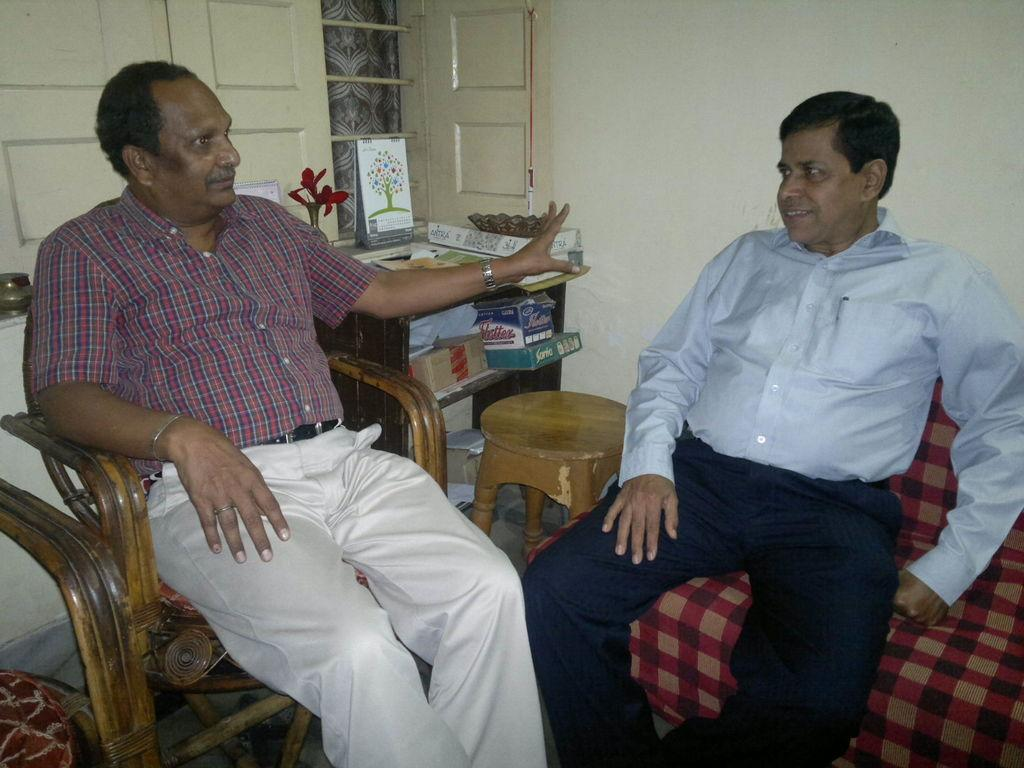How many men are seated in the image? There are two men seated on chairs in the image. What is one of the men doing in the image? There is a man speaking in the image. What is present in the image for people to gather around or use? There is a table in the image. What can be seen in the background of the image? There is a window in the image. What type of smell can be detected coming from the men in the image? There is no information about smells in the image, so it cannot be determined. --- Facts: 1. There is a car in the image. 2. The car is parked on the street. 3. There are trees lining the street. 4. The sky is visible in the image. 5. There is a traffic light in the image. Absurd Topics: parrot, sand, dance Conversation: What is the main subject of the image? The main subject of the image is a car. Where is the car located in the image? The car is parked on the street. What can be seen along the street in the image? There are trees lining the street. What is visible in the background of the image? The sky is visible in the image. What can be seen controlling the flow of traffic in the image? There is a traffic light in the image. Reasoning: Let's think step by step in order to produce the conversation. We start by identifying the main subject of the image, which is the car. Then, we describe the location of the car, which is parked on the street. Next, we mention the presence of trees along the street, which adds context to the setting. We then identify the sky in the background, which provides information about the weather or time of day. Finally, we acknowledge the presence of a traffic light, which is a common object for controlling traffic. Absurd Question/Answer: Can you tell me how many parrots are sitting on the car in the image? There are no parrots present in the image; it only features a car parked on the street. What type of dance is being performed by the sand in the image? There is no sand or dancing in the image; it only features a car parked on the street. 